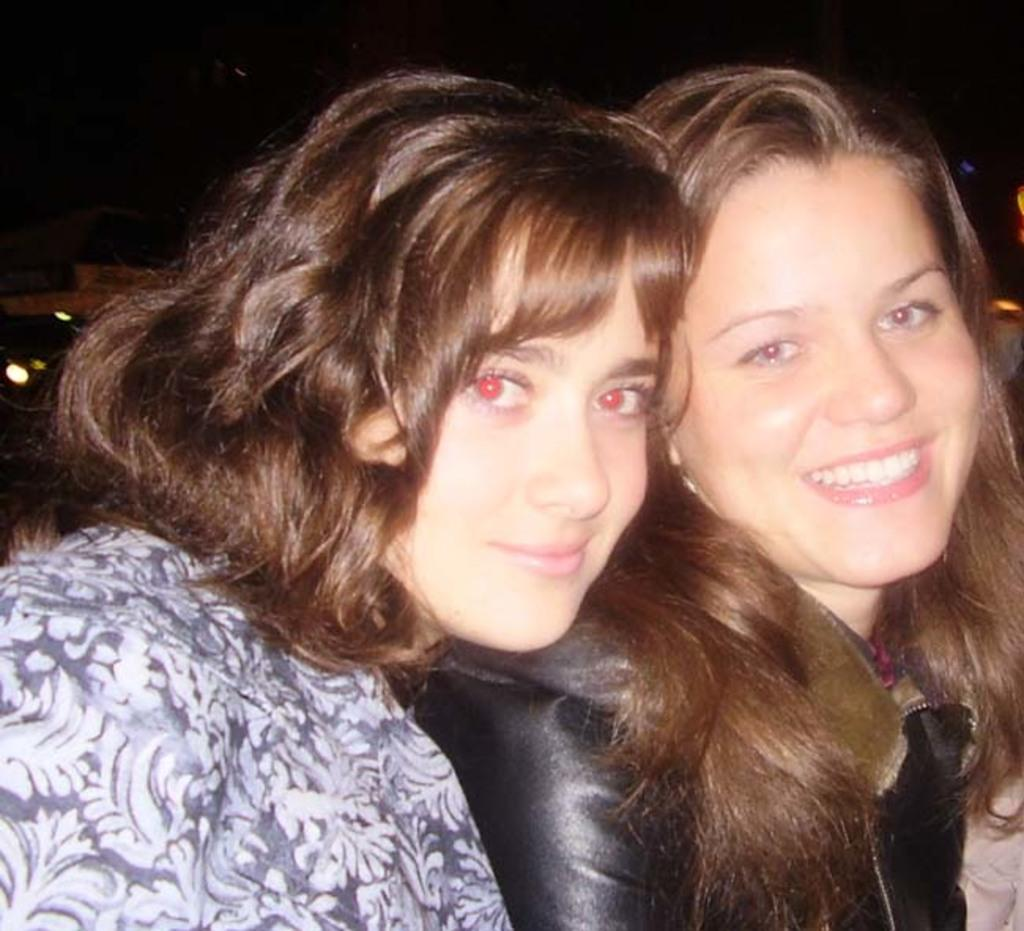How many people are in the image? There are two women in the image. What expressions do the women have in the image? Both women are smiling in the image. What type of cactus can be seen in the image? There is no cactus present in the image; it features two women smiling. What is the women using to flip the pancakes in the image? There are no pancakes or flipping tools present in the image. 